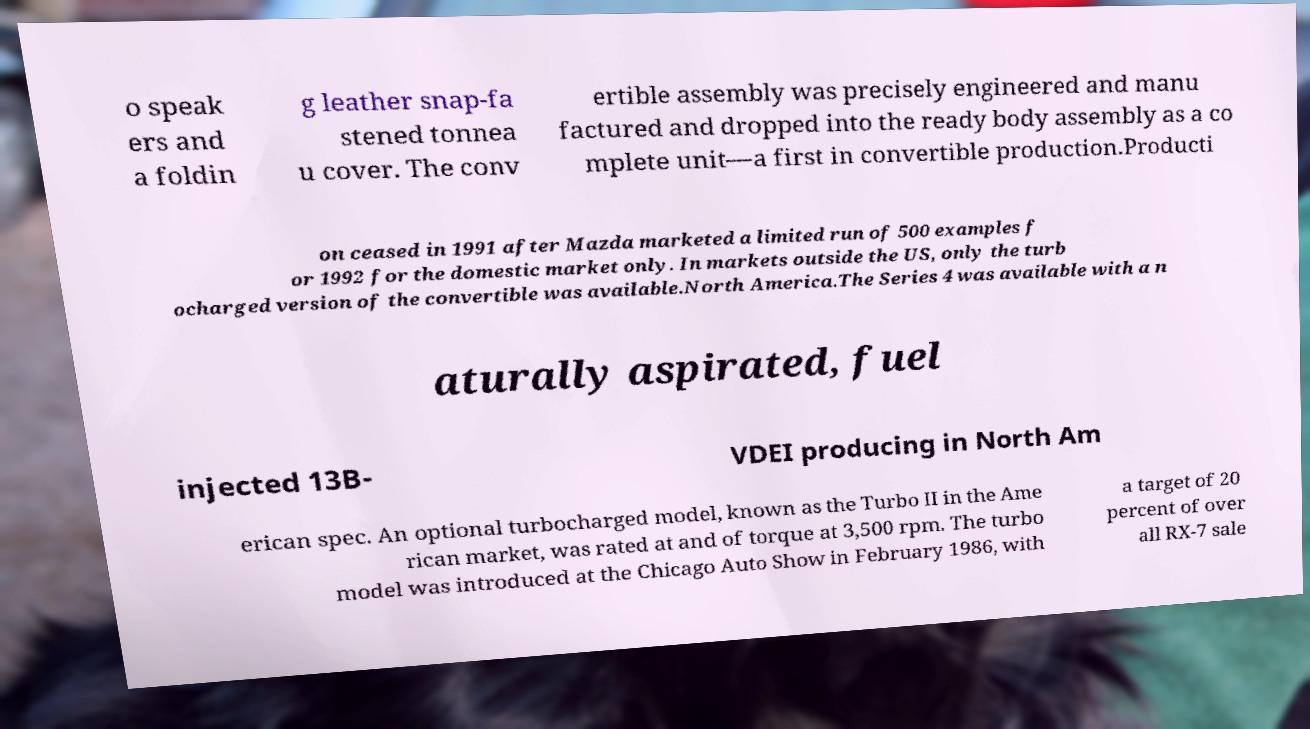Could you assist in decoding the text presented in this image and type it out clearly? o speak ers and a foldin g leather snap-fa stened tonnea u cover. The conv ertible assembly was precisely engineered and manu factured and dropped into the ready body assembly as a co mplete unit—a first in convertible production.Producti on ceased in 1991 after Mazda marketed a limited run of 500 examples f or 1992 for the domestic market only. In markets outside the US, only the turb ocharged version of the convertible was available.North America.The Series 4 was available with a n aturally aspirated, fuel injected 13B- VDEI producing in North Am erican spec. An optional turbocharged model, known as the Turbo II in the Ame rican market, was rated at and of torque at 3,500 rpm. The turbo model was introduced at the Chicago Auto Show in February 1986, with a target of 20 percent of over all RX-7 sale 